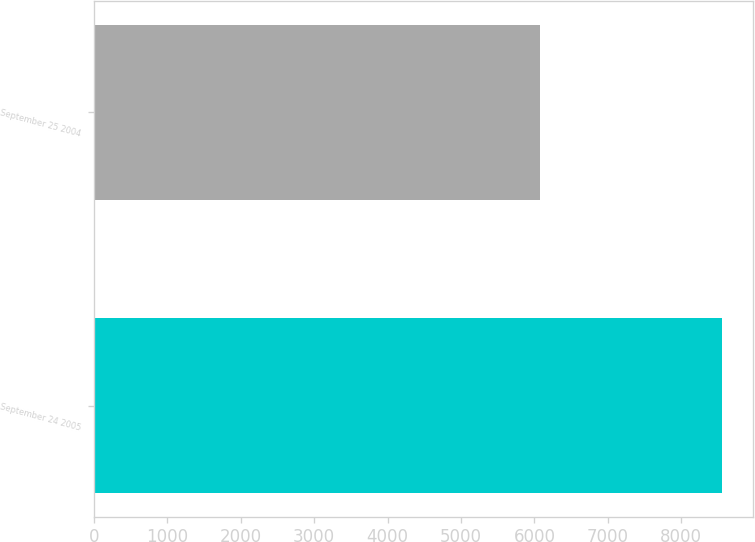Convert chart to OTSL. <chart><loc_0><loc_0><loc_500><loc_500><bar_chart><fcel>September 24 2005<fcel>September 25 2004<nl><fcel>8549<fcel>6082<nl></chart> 